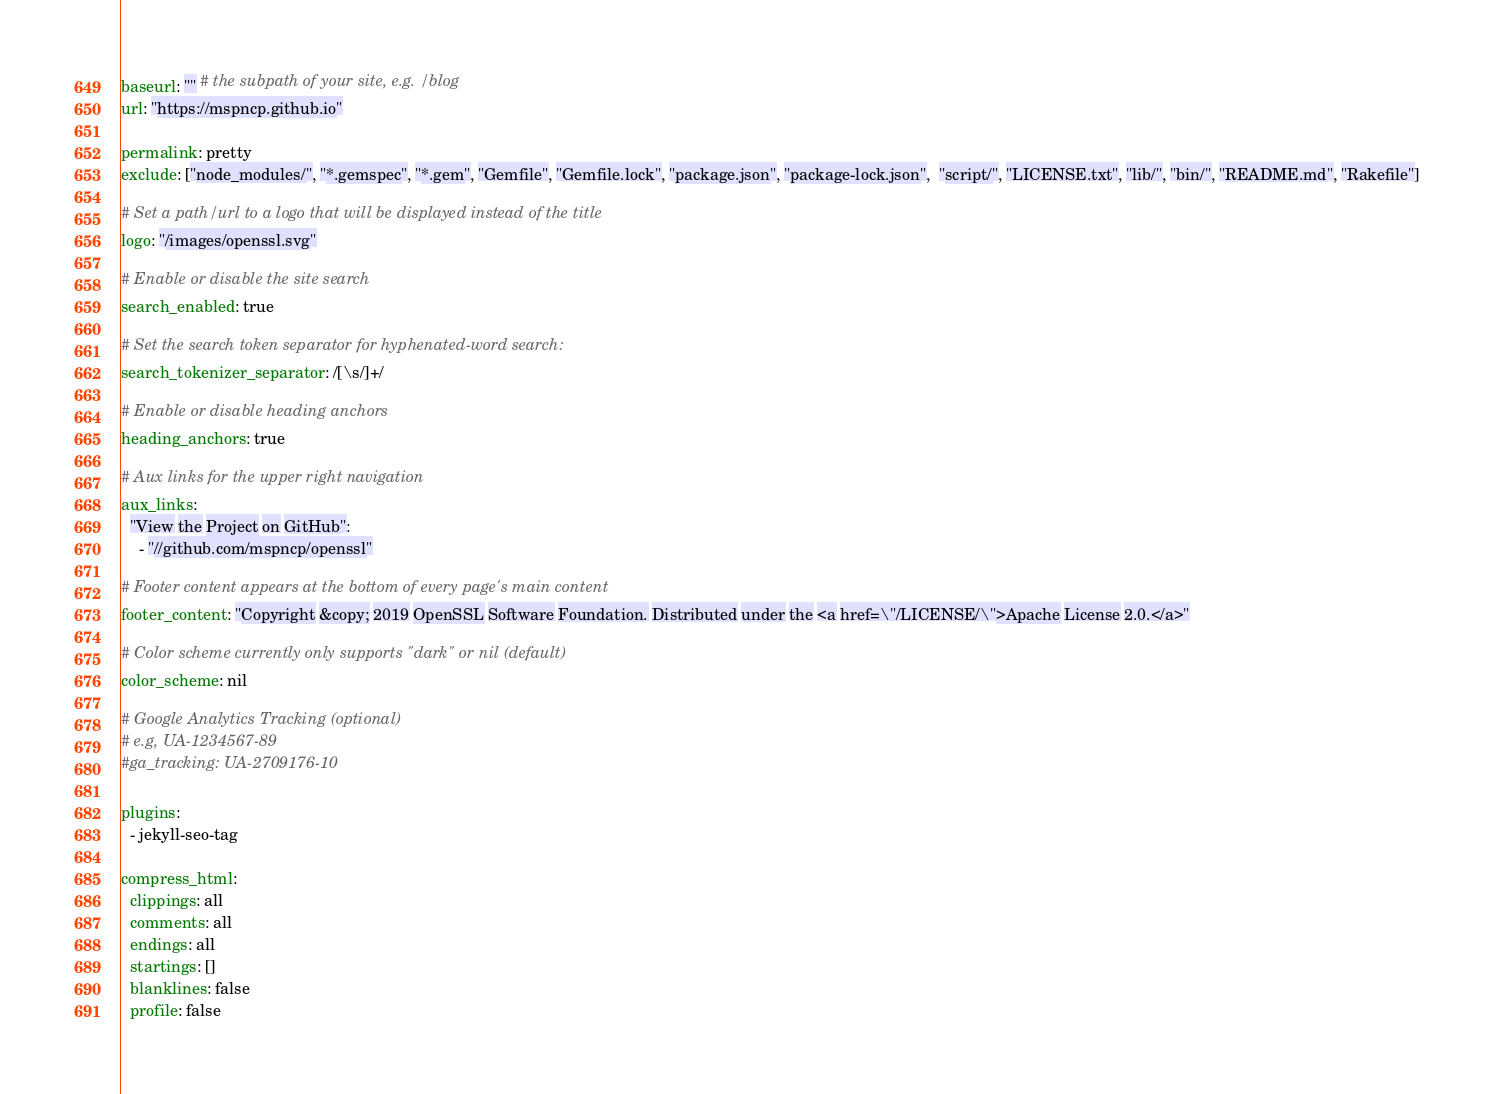Convert code to text. <code><loc_0><loc_0><loc_500><loc_500><_YAML_>baseurl: "" # the subpath of your site, e.g. /blog
url: "https://mspncp.github.io"

permalink: pretty
exclude: ["node_modules/", "*.gemspec", "*.gem", "Gemfile", "Gemfile.lock", "package.json", "package-lock.json",  "script/", "LICENSE.txt", "lib/", "bin/", "README.md", "Rakefile"]

# Set a path/url to a logo that will be displayed instead of the title
logo: "/images/openssl.svg"

# Enable or disable the site search
search_enabled: true

# Set the search token separator for hyphenated-word search:
search_tokenizer_separator: /[\s/]+/

# Enable or disable heading anchors
heading_anchors: true

# Aux links for the upper right navigation
aux_links:
  "View the Project on GitHub":
    - "//github.com/mspncp/openssl"

# Footer content appears at the bottom of every page's main content
footer_content: "Copyright &copy; 2019 OpenSSL Software Foundation. Distributed under the <a href=\"/LICENSE/\">Apache License 2.0.</a>"

# Color scheme currently only supports "dark" or nil (default)
color_scheme: nil

# Google Analytics Tracking (optional)
# e.g, UA-1234567-89
#ga_tracking: UA-2709176-10

plugins:
  - jekyll-seo-tag

compress_html:
  clippings: all
  comments: all
  endings: all
  startings: []
  blanklines: false
  profile: false</code> 